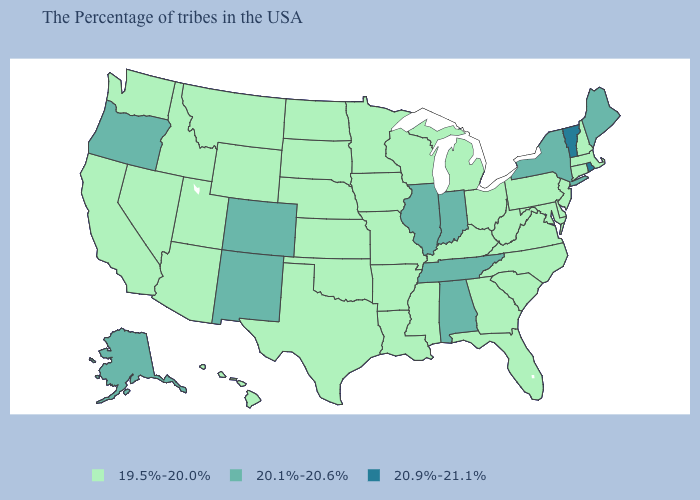Does Michigan have a lower value than Indiana?
Write a very short answer. Yes. Which states have the lowest value in the West?
Short answer required. Wyoming, Utah, Montana, Arizona, Idaho, Nevada, California, Washington, Hawaii. Name the states that have a value in the range 19.5%-20.0%?
Give a very brief answer. Massachusetts, New Hampshire, Connecticut, New Jersey, Delaware, Maryland, Pennsylvania, Virginia, North Carolina, South Carolina, West Virginia, Ohio, Florida, Georgia, Michigan, Kentucky, Wisconsin, Mississippi, Louisiana, Missouri, Arkansas, Minnesota, Iowa, Kansas, Nebraska, Oklahoma, Texas, South Dakota, North Dakota, Wyoming, Utah, Montana, Arizona, Idaho, Nevada, California, Washington, Hawaii. Which states have the highest value in the USA?
Be succinct. Rhode Island, Vermont. Does the map have missing data?
Quick response, please. No. Does Vermont have the highest value in the USA?
Keep it brief. Yes. Which states hav the highest value in the MidWest?
Be succinct. Indiana, Illinois. Is the legend a continuous bar?
Concise answer only. No. Among the states that border Tennessee , which have the highest value?
Concise answer only. Alabama. Among the states that border Delaware , which have the lowest value?
Quick response, please. New Jersey, Maryland, Pennsylvania. Name the states that have a value in the range 20.1%-20.6%?
Be succinct. Maine, New York, Indiana, Alabama, Tennessee, Illinois, Colorado, New Mexico, Oregon, Alaska. Does the map have missing data?
Quick response, please. No. What is the value of New York?
Short answer required. 20.1%-20.6%. Does Oregon have the highest value in the West?
Short answer required. Yes. 